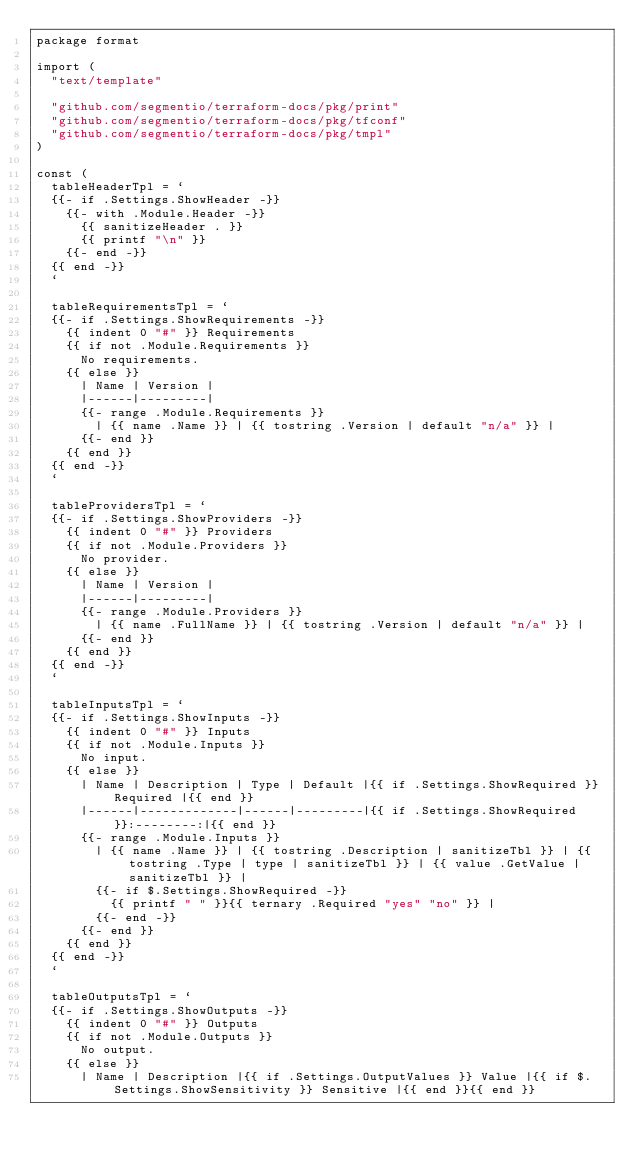<code> <loc_0><loc_0><loc_500><loc_500><_Go_>package format

import (
	"text/template"

	"github.com/segmentio/terraform-docs/pkg/print"
	"github.com/segmentio/terraform-docs/pkg/tfconf"
	"github.com/segmentio/terraform-docs/pkg/tmpl"
)

const (
	tableHeaderTpl = `
	{{- if .Settings.ShowHeader -}}
		{{- with .Module.Header -}}
			{{ sanitizeHeader . }}
			{{ printf "\n" }}
		{{- end -}}
	{{ end -}}
	`

	tableRequirementsTpl = `
	{{- if .Settings.ShowRequirements -}}
		{{ indent 0 "#" }} Requirements
		{{ if not .Module.Requirements }}
			No requirements.
		{{ else }}
			| Name | Version |
			|------|---------|
			{{- range .Module.Requirements }}
				| {{ name .Name }} | {{ tostring .Version | default "n/a" }} |
			{{- end }}
		{{ end }}
	{{ end -}}
	`

	tableProvidersTpl = `
	{{- if .Settings.ShowProviders -}}
		{{ indent 0 "#" }} Providers
		{{ if not .Module.Providers }}
			No provider.
		{{ else }}
			| Name | Version |
			|------|---------|
			{{- range .Module.Providers }}
				| {{ name .FullName }} | {{ tostring .Version | default "n/a" }} |
			{{- end }}
		{{ end }}
	{{ end -}}
	`

	tableInputsTpl = `
	{{- if .Settings.ShowInputs -}}
		{{ indent 0 "#" }} Inputs
		{{ if not .Module.Inputs }}
			No input.
		{{ else }}
			| Name | Description | Type | Default |{{ if .Settings.ShowRequired }} Required |{{ end }}
			|------|-------------|------|---------|{{ if .Settings.ShowRequired }}:--------:|{{ end }}
			{{- range .Module.Inputs }}
				| {{ name .Name }} | {{ tostring .Description | sanitizeTbl }} | {{ tostring .Type | type | sanitizeTbl }} | {{ value .GetValue | sanitizeTbl }} |
				{{- if $.Settings.ShowRequired -}}
					{{ printf " " }}{{ ternary .Required "yes" "no" }} |
				{{- end -}}
			{{- end }}
		{{ end }}
	{{ end -}}
	`

	tableOutputsTpl = `
	{{- if .Settings.ShowOutputs -}}
		{{ indent 0 "#" }} Outputs
		{{ if not .Module.Outputs }}
			No output.
		{{ else }}
			| Name | Description |{{ if .Settings.OutputValues }} Value |{{ if $.Settings.ShowSensitivity }} Sensitive |{{ end }}{{ end }}</code> 